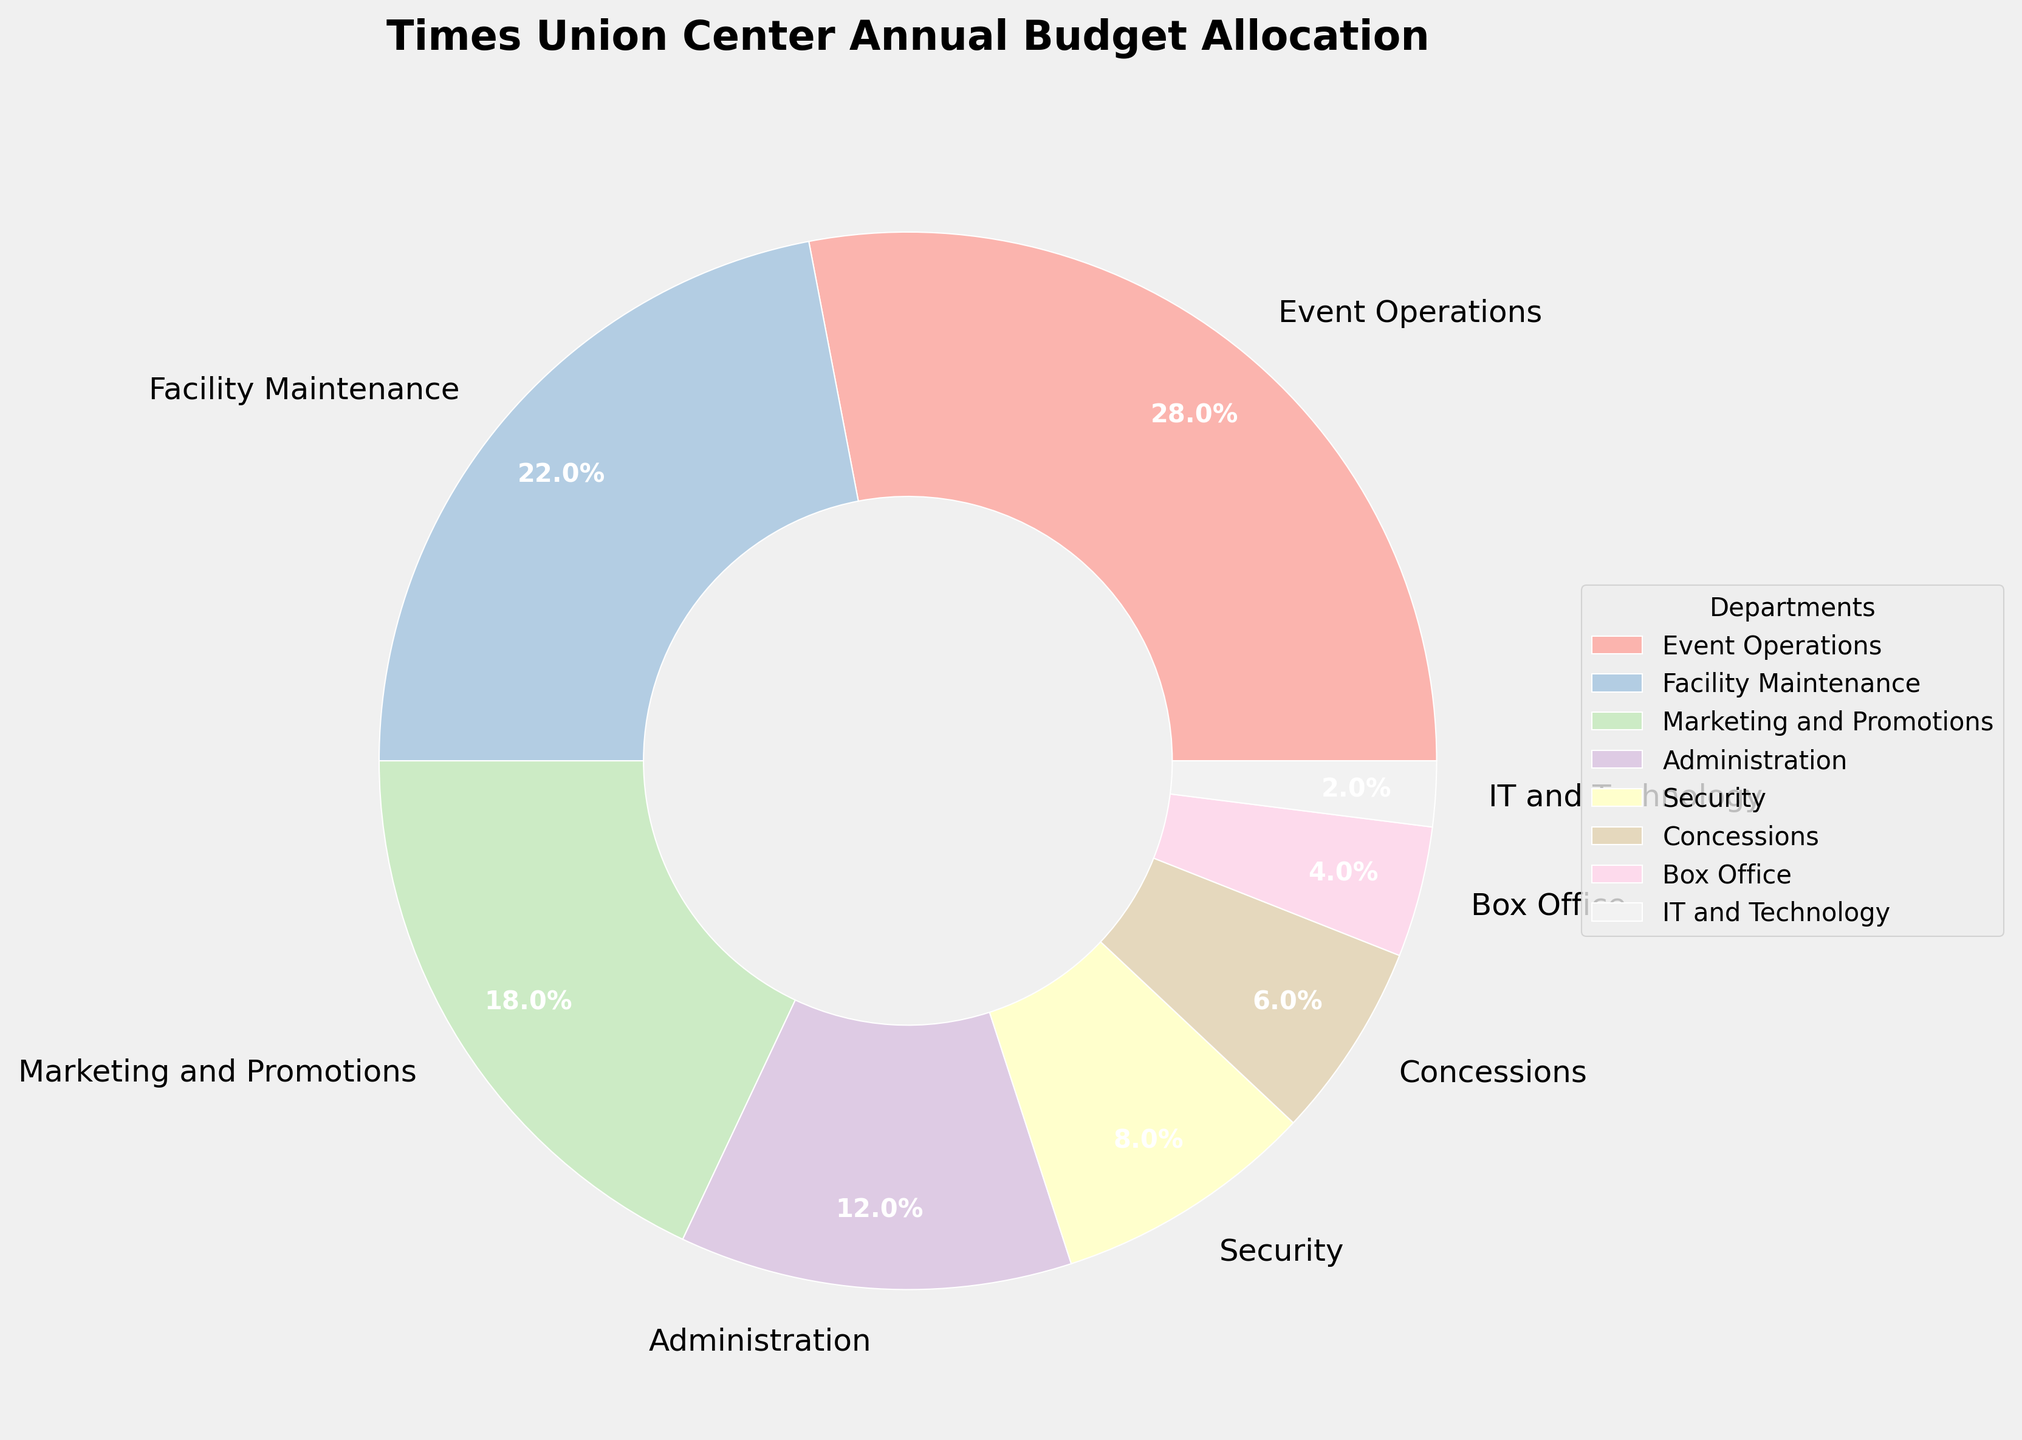What percentage of the budget is allocated to Administration and Marketing and Promotions combined? Add the percentages for Administration (12%) and Marketing and Promotions (18%): 12% + 18% = 30%
Answer: 30% Which department receives the highest budget allocation? Look for the department with the largest percentage on the pie chart. Event Operations has the highest percentage at 28%
Answer: Event Operations What is the total budget percentage allocated to all departments except Facility Maintenance and Security? Add the percentages of all other departments: Event Operations (28%) + Marketing and Promotions (18%) + Administration (12%) + Concessions (6%) + Box Office (4%) + IT and Technology (2%) = 70%
Answer: 70% Between Security and IT and Technology, which department has a lower budget allocation? Compare the percentages: Security has 8% and IT and Technology has 2%. IT and Technology has the lower budget allocation
Answer: IT and Technology Is the budget allocation for Facility Maintenance more than double that of Concessions? Facility Maintenance has 22%, and Concessions has 6%. Double of 6% is 12%. Since 22% > 12%, the budget allocation for Facility Maintenance is more than double that of Concessions
Answer: Yes How does the allocation for Event Operations compare to that of Box Office? Event Operations has 28% and Box Office has 4%. 28% is significantly larger than 4%
Answer: Event Operations' allocation is higher What is the difference in budget allocation between Marketing and Promotions and Security? Subtract the percentage for Security (8%) from Marketing and Promotions (18%): 18% - 8% = 10%
Answer: 10% What percentage of the budget is allocated to departments other than Event Operations and Marketing and Promotions? Add the percentages of all other departments: Facility Maintenance (22%) + Administration (12%) + Security (8%) + Concessions (6%) + Box Office (4%) + IT and Technology (2%) = 54%
Answer: 54% Which department has the second-highest budget allocation? The second-largest segment on the pie chart corresponds to Facility Maintenance at 22%
Answer: Facility Maintenance What is the combined budget allocation for all departments that receive less than 10% each? Add the percentages for all departments with less than 10%: Administration (12%), Security (8%), Concessions (6%), Box Office (4%), and IT and Technology (2%) = 8% + 6% + 4% + 2% = 20%
Answer: 20% 